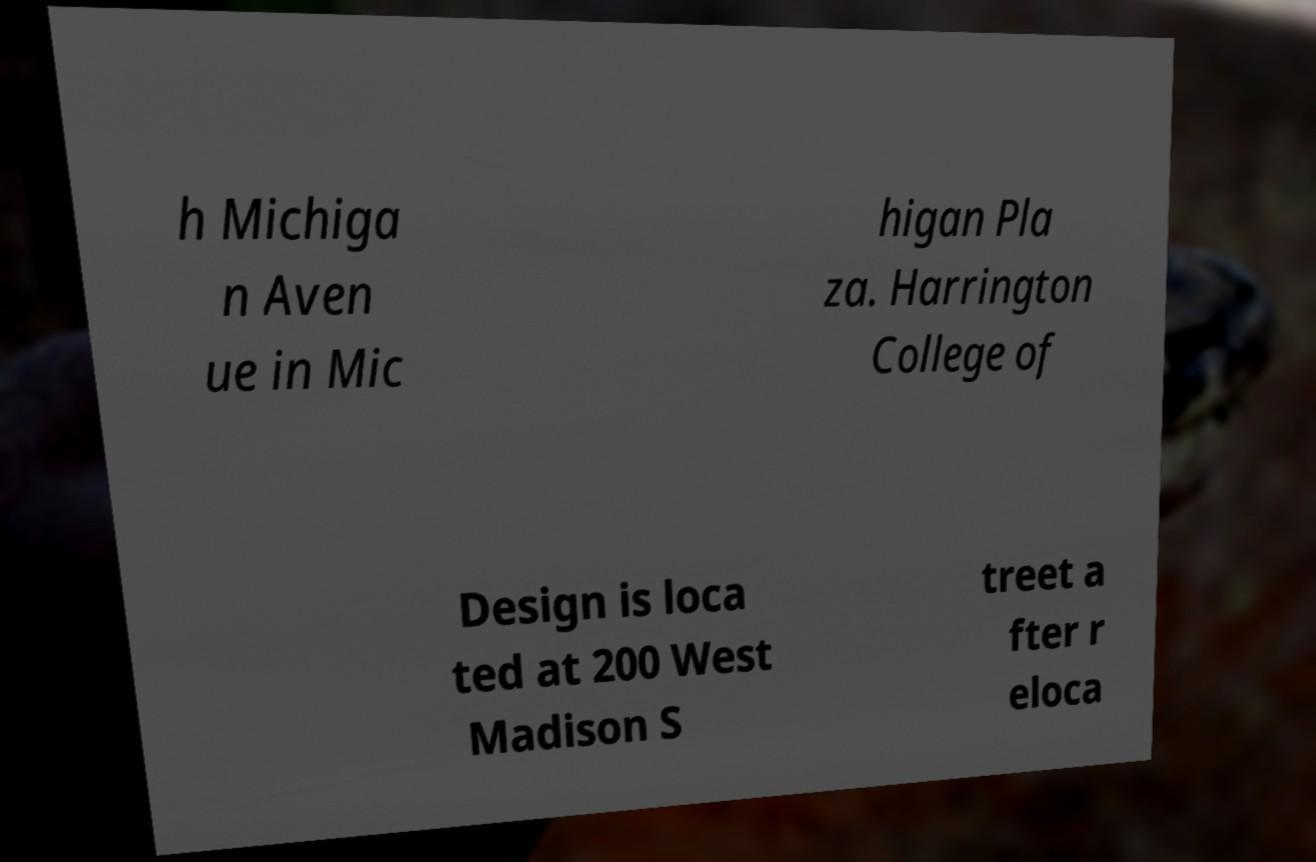I need the written content from this picture converted into text. Can you do that? h Michiga n Aven ue in Mic higan Pla za. Harrington College of Design is loca ted at 200 West Madison S treet a fter r eloca 